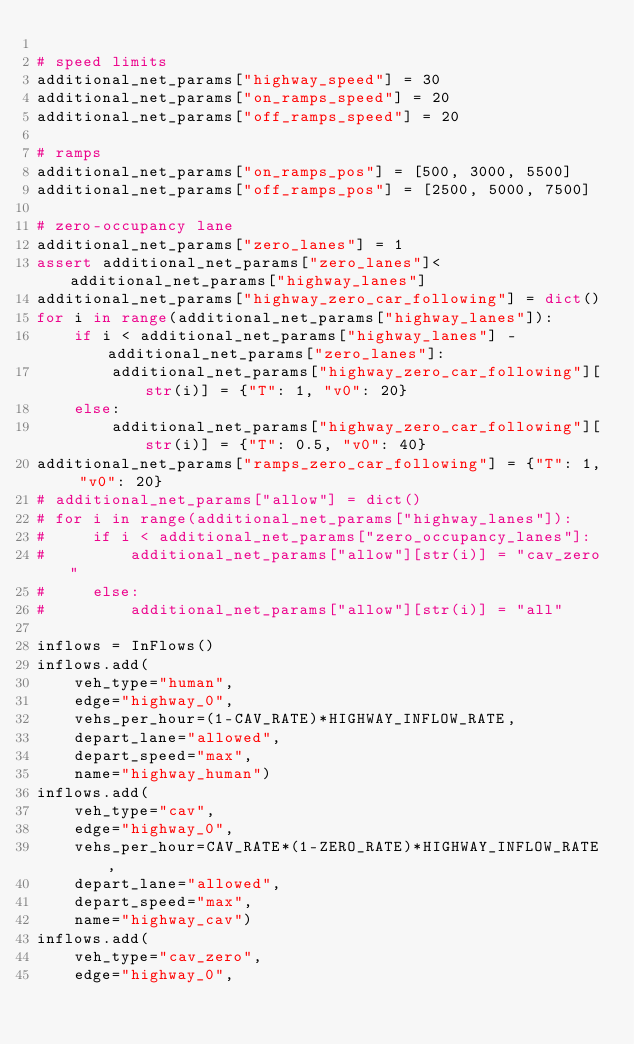<code> <loc_0><loc_0><loc_500><loc_500><_Python_>
# speed limits
additional_net_params["highway_speed"] = 30
additional_net_params["on_ramps_speed"] = 20
additional_net_params["off_ramps_speed"] = 20

# ramps
additional_net_params["on_ramps_pos"] = [500, 3000, 5500]
additional_net_params["off_ramps_pos"] = [2500, 5000, 7500]

# zero-occupancy lane
additional_net_params["zero_lanes"] = 1
assert additional_net_params["zero_lanes"]<additional_net_params["highway_lanes"]
additional_net_params["highway_zero_car_following"] = dict()
for i in range(additional_net_params["highway_lanes"]):
    if i < additional_net_params["highway_lanes"] - additional_net_params["zero_lanes"]:
        additional_net_params["highway_zero_car_following"][str(i)] = {"T": 1, "v0": 20}
    else:
        additional_net_params["highway_zero_car_following"][str(i)] = {"T": 0.5, "v0": 40}
additional_net_params["ramps_zero_car_following"] = {"T": 1, "v0": 20}
# additional_net_params["allow"] = dict()
# for i in range(additional_net_params["highway_lanes"]):
#     if i < additional_net_params["zero_occupancy_lanes"]:
#         additional_net_params["allow"][str(i)] = "cav_zero"
#     else:
#         additional_net_params["allow"][str(i)] = "all"

inflows = InFlows()
inflows.add(
    veh_type="human",
    edge="highway_0",
    vehs_per_hour=(1-CAV_RATE)*HIGHWAY_INFLOW_RATE,
    depart_lane="allowed",
    depart_speed="max",
    name="highway_human")
inflows.add(
    veh_type="cav",
    edge="highway_0",
    vehs_per_hour=CAV_RATE*(1-ZERO_RATE)*HIGHWAY_INFLOW_RATE,
    depart_lane="allowed",
    depart_speed="max",
    name="highway_cav")
inflows.add(
    veh_type="cav_zero",
    edge="highway_0",</code> 